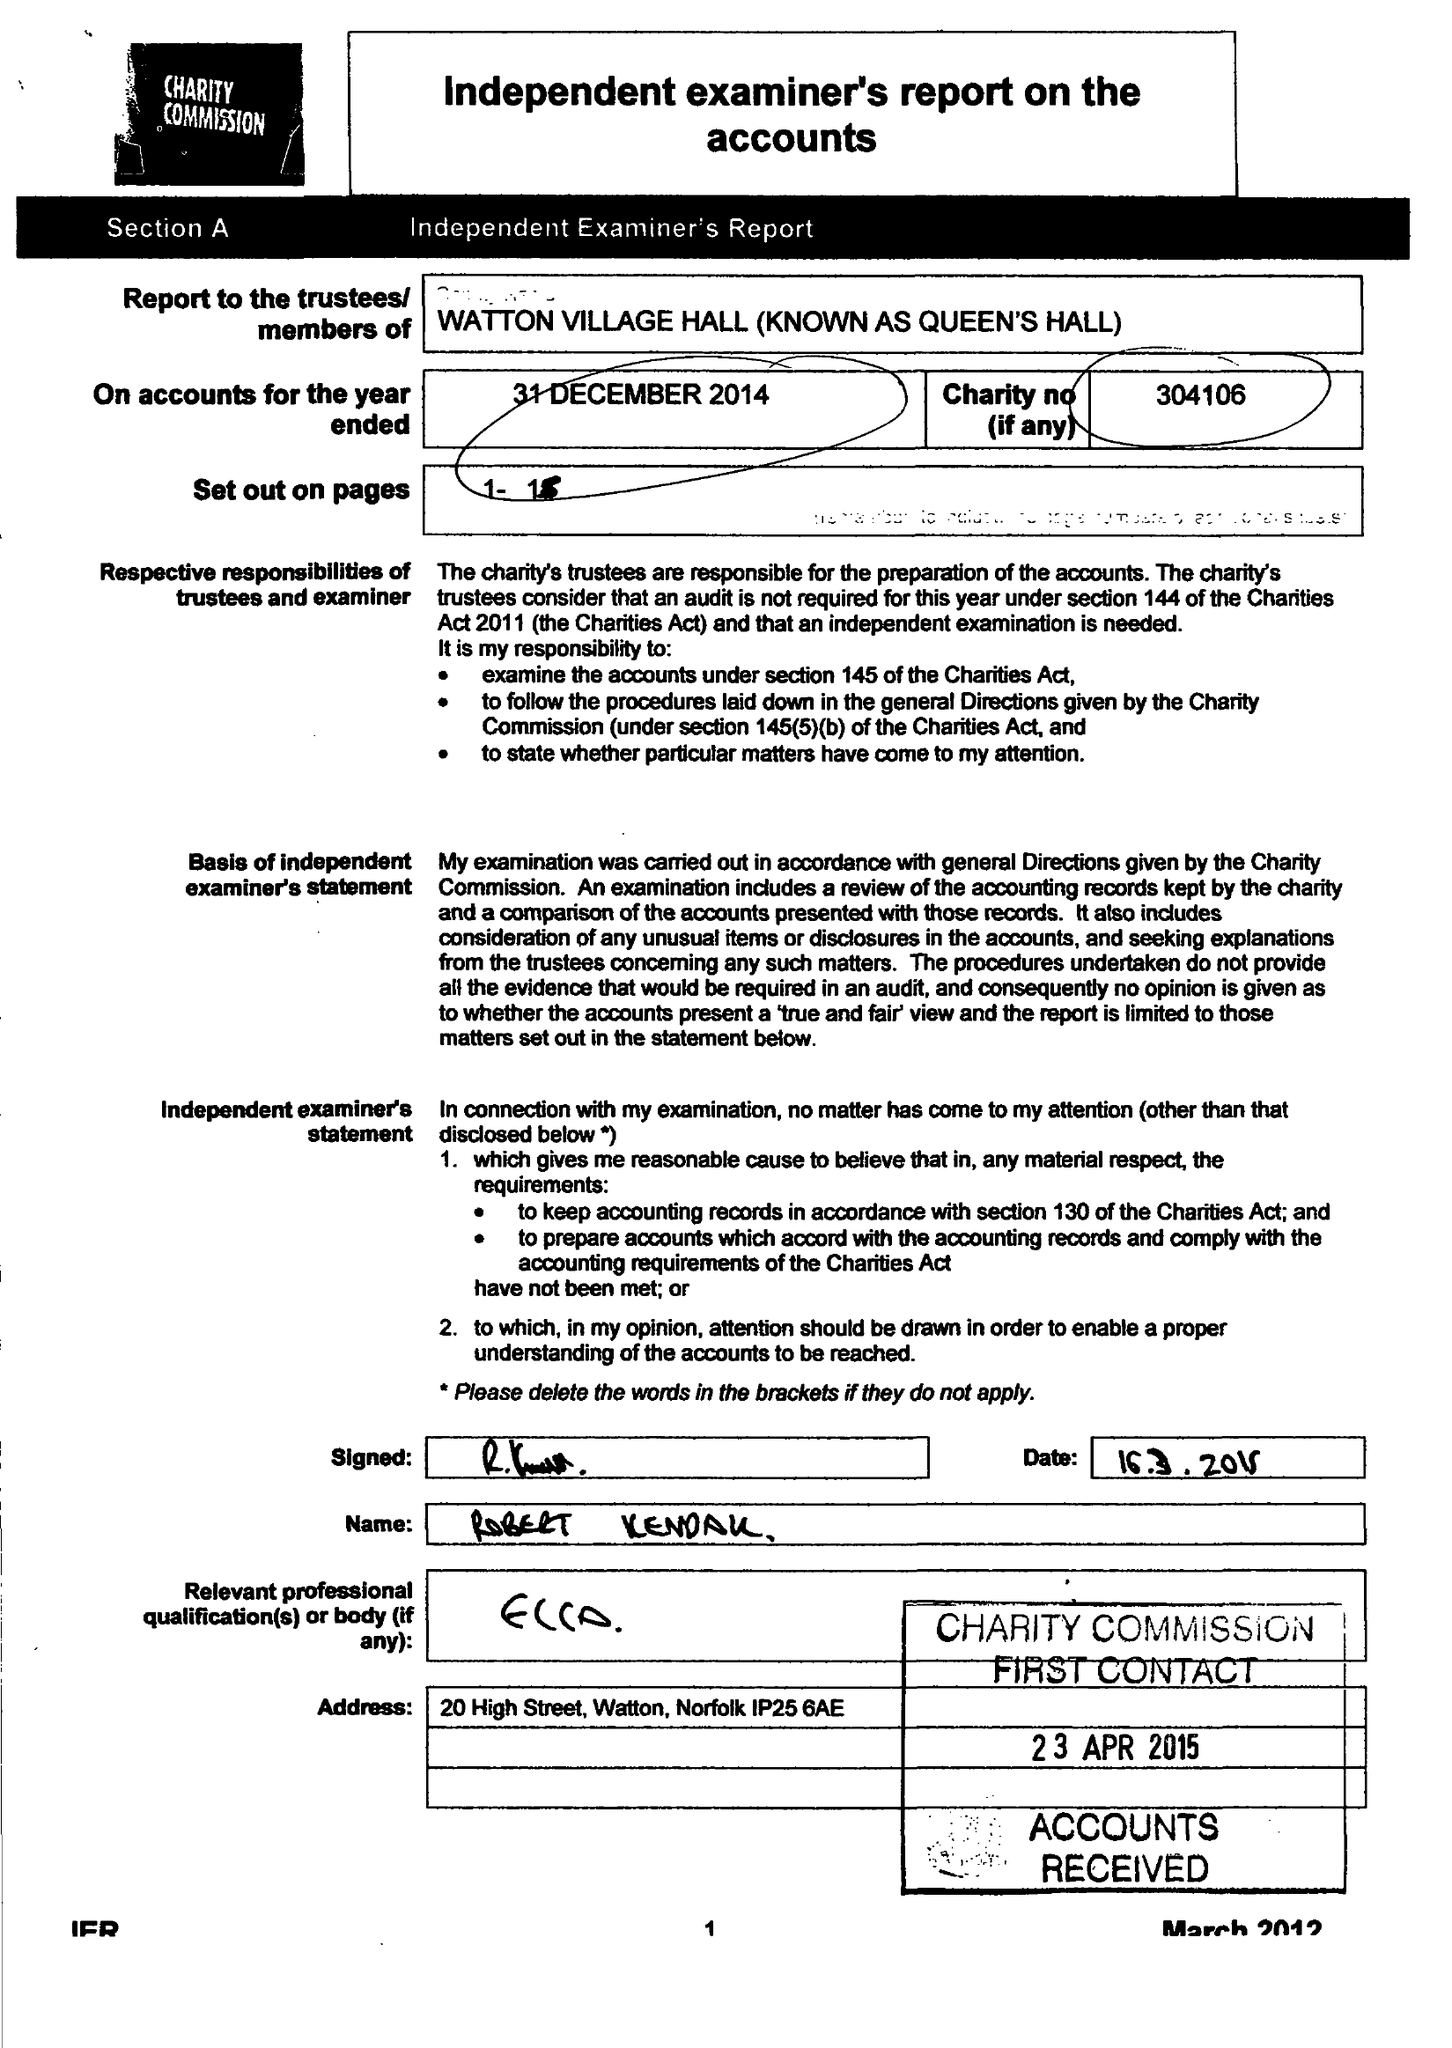What is the value for the address__street_line?
Answer the question using a single word or phrase. None 